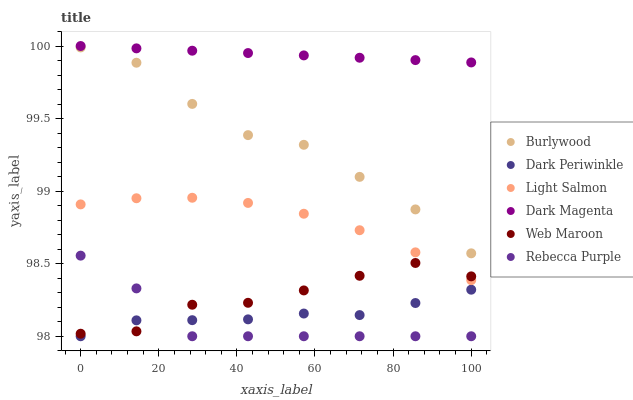Does Rebecca Purple have the minimum area under the curve?
Answer yes or no. Yes. Does Dark Magenta have the maximum area under the curve?
Answer yes or no. Yes. Does Burlywood have the minimum area under the curve?
Answer yes or no. No. Does Burlywood have the maximum area under the curve?
Answer yes or no. No. Is Dark Magenta the smoothest?
Answer yes or no. Yes. Is Burlywood the roughest?
Answer yes or no. Yes. Is Burlywood the smoothest?
Answer yes or no. No. Is Dark Magenta the roughest?
Answer yes or no. No. Does Rebecca Purple have the lowest value?
Answer yes or no. Yes. Does Burlywood have the lowest value?
Answer yes or no. No. Does Dark Magenta have the highest value?
Answer yes or no. Yes. Does Burlywood have the highest value?
Answer yes or no. No. Is Burlywood less than Dark Magenta?
Answer yes or no. Yes. Is Light Salmon greater than Dark Periwinkle?
Answer yes or no. Yes. Does Web Maroon intersect Dark Periwinkle?
Answer yes or no. Yes. Is Web Maroon less than Dark Periwinkle?
Answer yes or no. No. Is Web Maroon greater than Dark Periwinkle?
Answer yes or no. No. Does Burlywood intersect Dark Magenta?
Answer yes or no. No. 